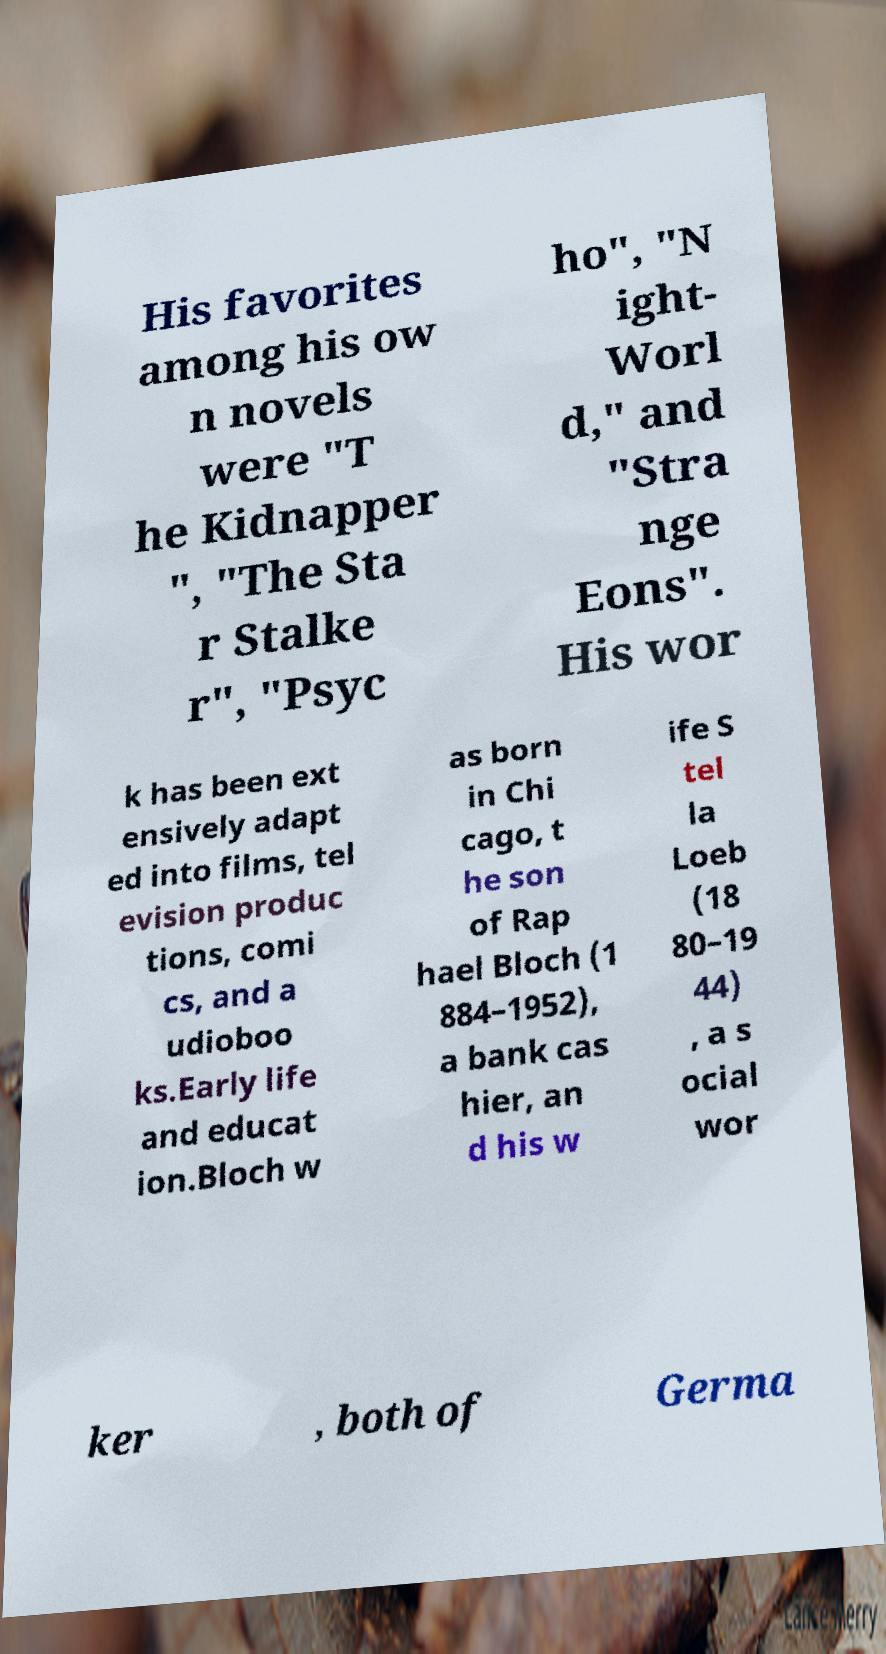What messages or text are displayed in this image? I need them in a readable, typed format. His favorites among his ow n novels were "T he Kidnapper ", "The Sta r Stalke r", "Psyc ho", "N ight- Worl d," and "Stra nge Eons". His wor k has been ext ensively adapt ed into films, tel evision produc tions, comi cs, and a udioboo ks.Early life and educat ion.Bloch w as born in Chi cago, t he son of Rap hael Bloch (1 884–1952), a bank cas hier, an d his w ife S tel la Loeb (18 80–19 44) , a s ocial wor ker , both of Germa 